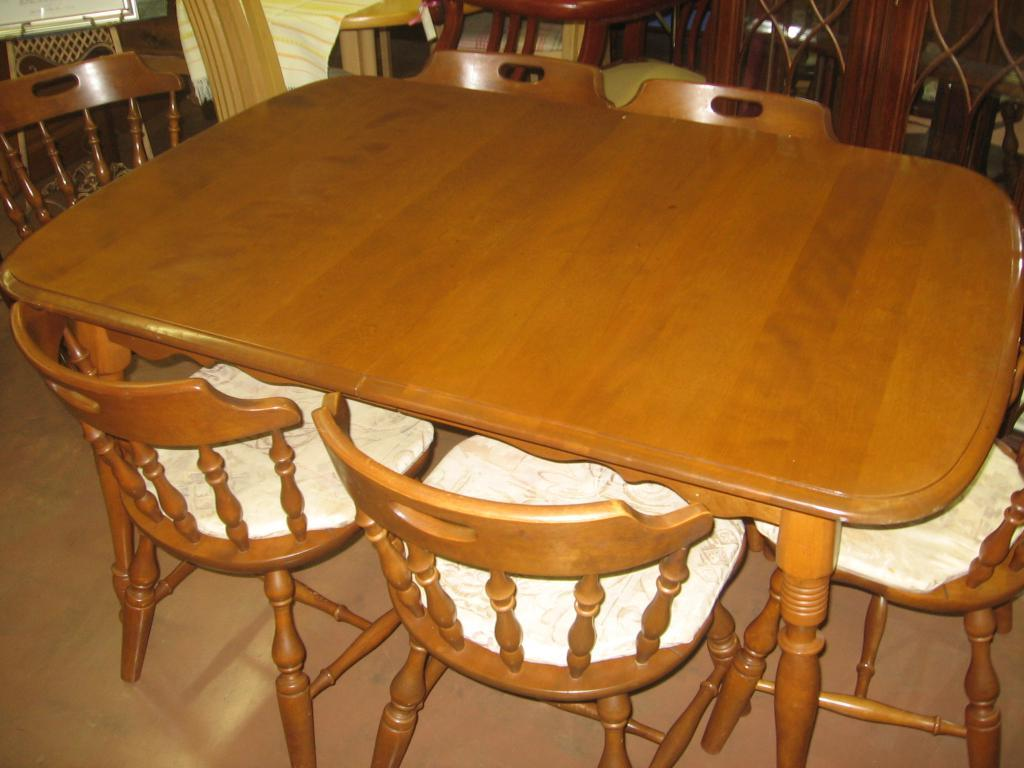What type of furniture is in the image? There is a dining table in the image. What is typically used with a dining table? Chairs are present around the dining table. How many firemen are sitting on the chairs around the dining table in the image? There are no firemen present in the image; it only shows a dining table and chairs. What type of bean is being served on the dining table in the image? There is no bean present in the image; it only shows a dining table and chairs. 